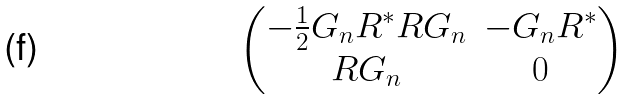<formula> <loc_0><loc_0><loc_500><loc_500>\begin{pmatrix} - \frac { 1 } { 2 } G _ { n } R ^ { * } R G _ { n } & - G _ { n } R ^ { * } \\ R G _ { n } & 0 \end{pmatrix}</formula> 